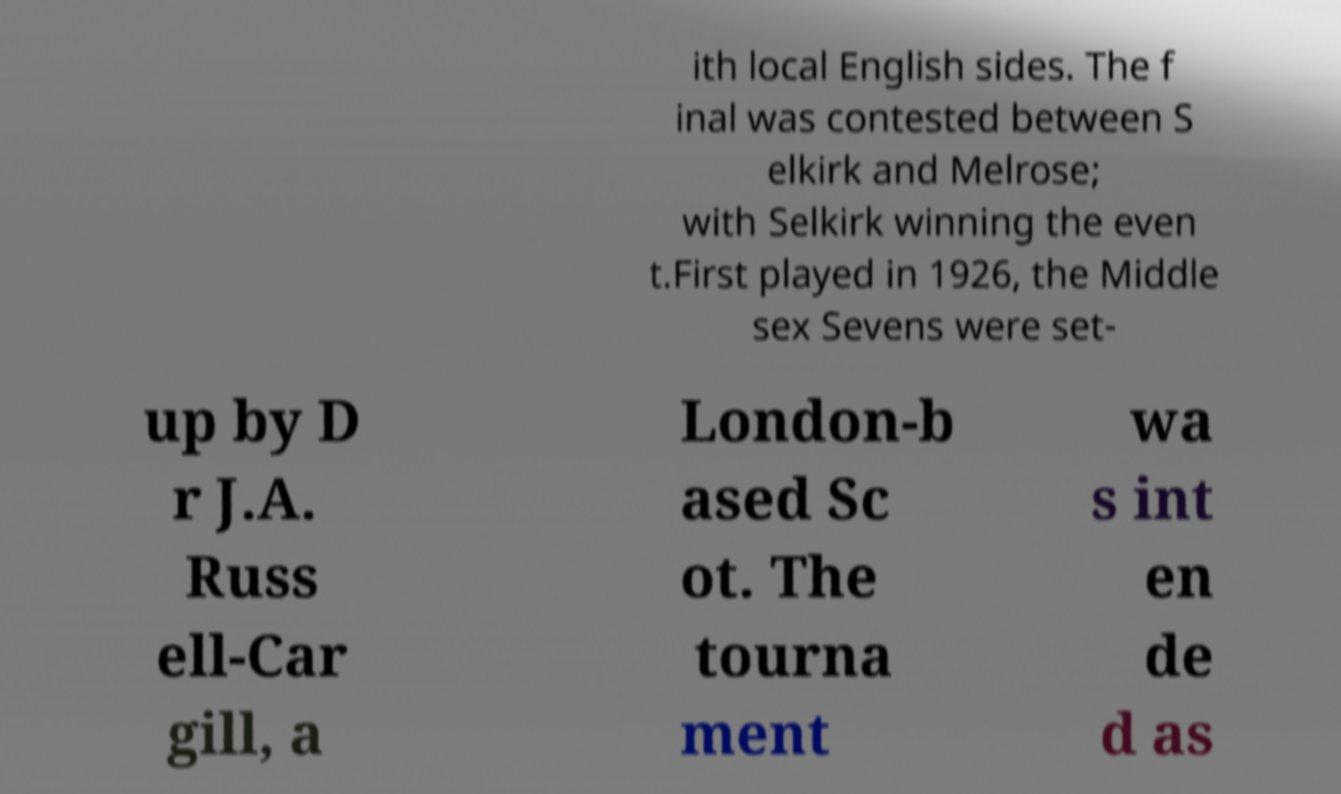Can you read and provide the text displayed in the image?This photo seems to have some interesting text. Can you extract and type it out for me? ith local English sides. The f inal was contested between S elkirk and Melrose; with Selkirk winning the even t.First played in 1926, the Middle sex Sevens were set- up by D r J.A. Russ ell-Car gill, a London-b ased Sc ot. The tourna ment wa s int en de d as 